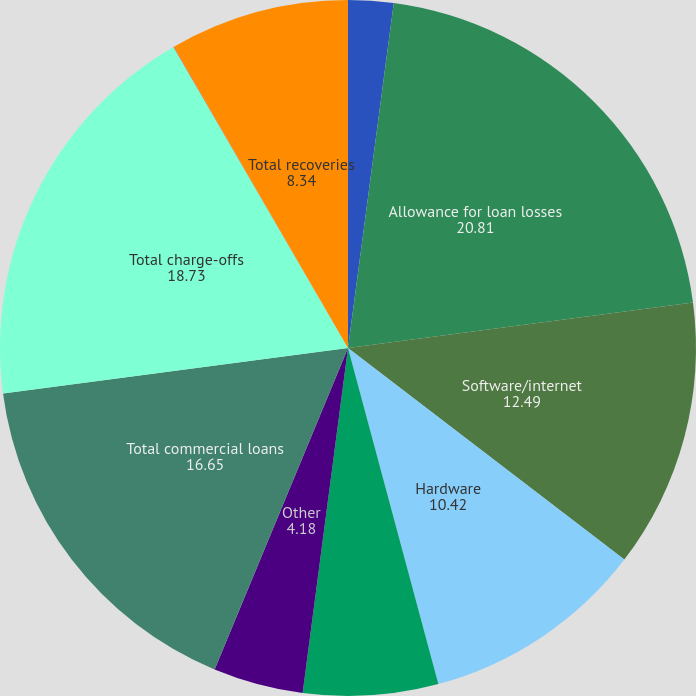Convert chart. <chart><loc_0><loc_0><loc_500><loc_500><pie_chart><fcel>(Dollars in thousands)<fcel>Allowance for loan losses<fcel>Software/internet<fcel>Hardware<fcel>Life science/healthcare<fcel>Other<fcel>Total commercial loans<fcel>Total charge-offs<fcel>Consumer loans<fcel>Total recoveries<nl><fcel>2.1%<fcel>20.81%<fcel>12.49%<fcel>10.42%<fcel>6.26%<fcel>4.18%<fcel>16.65%<fcel>18.73%<fcel>0.02%<fcel>8.34%<nl></chart> 